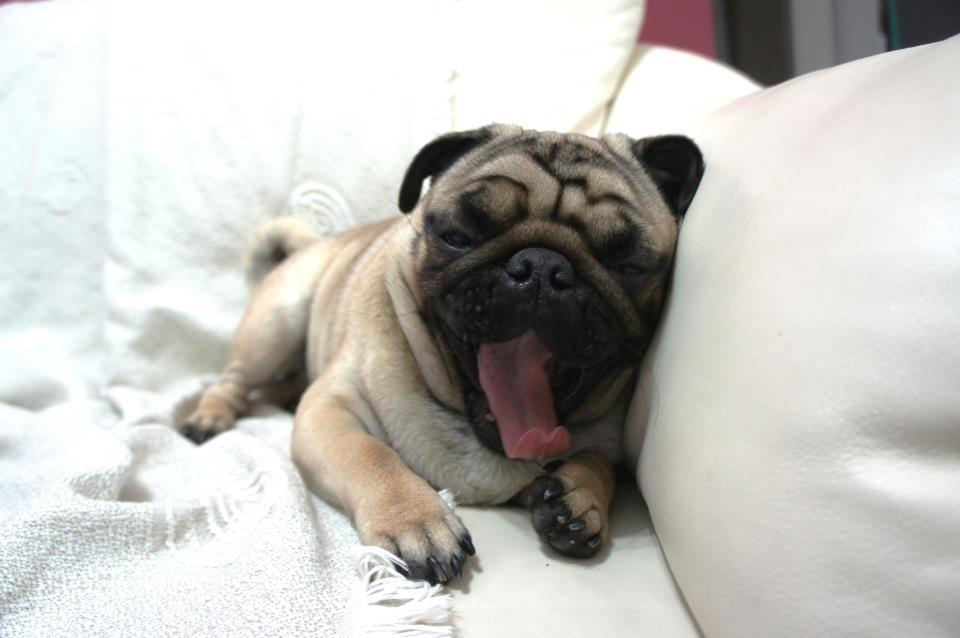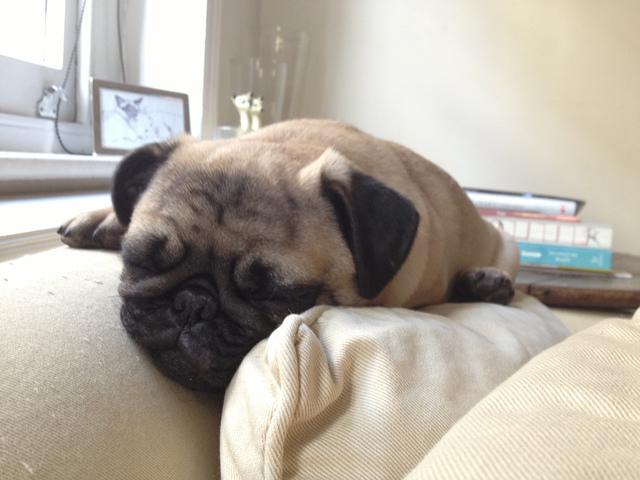The first image is the image on the left, the second image is the image on the right. For the images displayed, is the sentence "Each image shows one dog lounging on a soft cushioned surface." factually correct? Answer yes or no. Yes. The first image is the image on the left, the second image is the image on the right. Given the left and right images, does the statement "Not one of the dogs is laying on a sofa." hold true? Answer yes or no. No. 